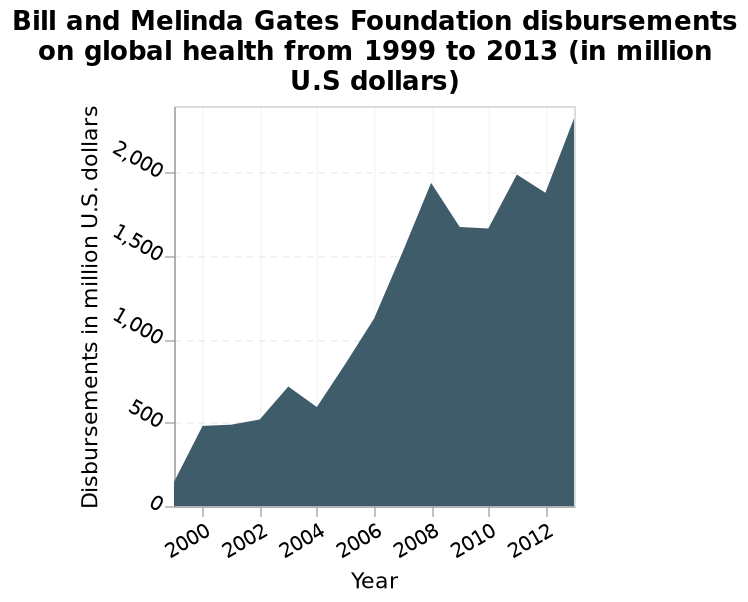<image>
please describe the details of the chart This area diagram is called Bill and Melinda Gates Foundation disbursements on global health from 1999 to 2013 (in million U.S dollars). Year is drawn along the x-axis. A linear scale with a minimum of 0 and a maximum of 2,000 can be seen on the y-axis, labeled Disbursements in million U.S. dollars. What is represented on the x-axis of the area diagram?  The years from 1999 to 2013 are represented on the x-axis of the area diagram. What was the highest growth period for the Foundation's disbursements? The highest growth period for the disbursements was between 2004 and 2008. 